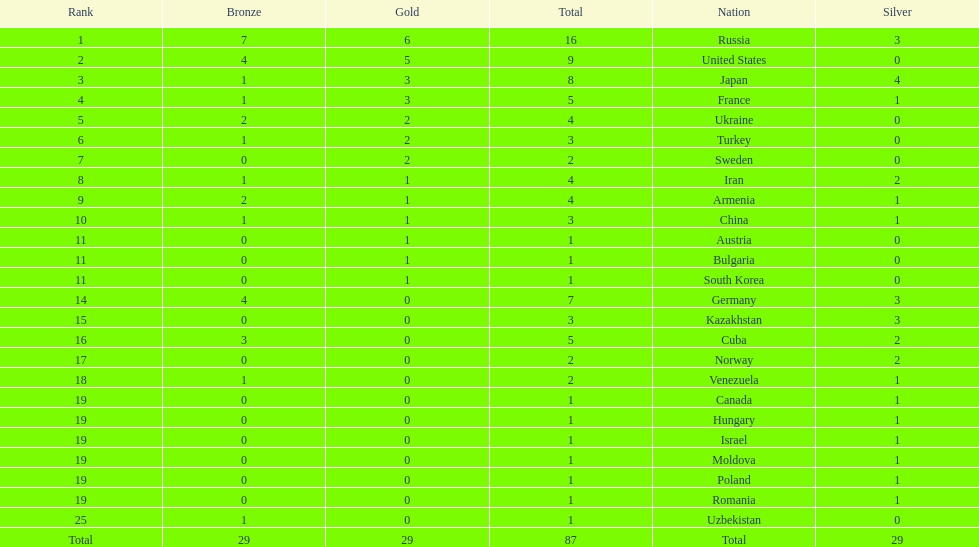Which nation has one gold medal but zero in both silver and bronze? Austria. 